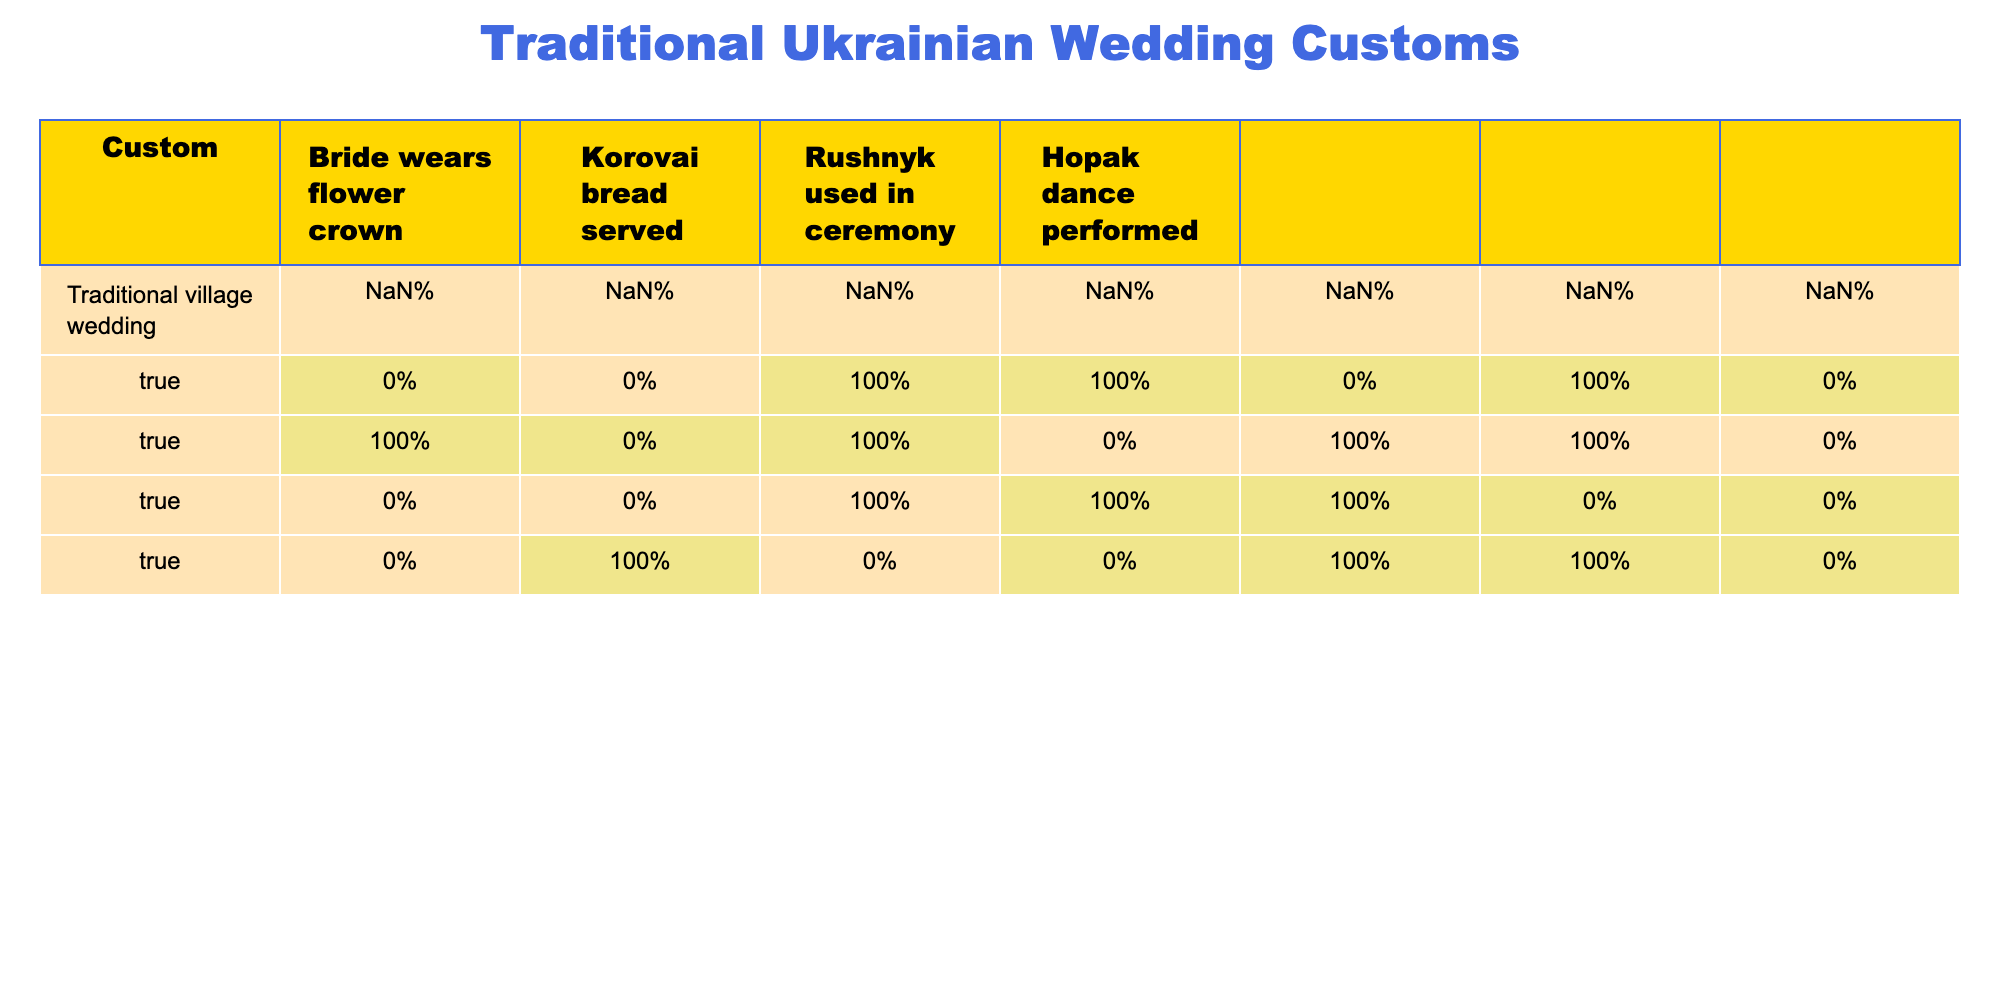What traditional wedding customs involve the bride wearing a flower crown? We can look at the table and list the types of weddings where the bride wears a flower crown. These are: Traditional village wedding, Family-only small ceremony, Mixed Ukrainian-foreign wedding, and Outdoor summer wedding.
Answer: Traditional village wedding, Family-only small ceremony, Mixed Ukrainian-foreign wedding, Outdoor summer wedding How many wedding types serve Korovai bread and perform the Hopak dance? The wedding types that serve Korovai bread are: Traditional village wedding, Modern city-influenced wedding, Family-only small ceremony, Winter wedding, Outdoor summer wedding. In total, there are 5 of them. However, only Traditional village wedding and Winter wedding also perform the Hopak dance (2 in total).
Answer: 2 Is the Rushnyk used in the Modern city-influenced wedding? According to the table, in the row for Modern city-influenced wedding, under the column Rushnyk used in ceremony, the value is FALSE. Therefore, Rushnyk is not used in this type of wedding.
Answer: No Which wedding types do not serve Korovai bread? To determine this, we can look at the table and find the rows where Korovai bread is marked as FALSE. These are: Modern city-influenced wedding and Destination wedding abroad.
Answer: Modern city-influenced wedding, Destination wedding abroad What is the relationship between the presence of the Hopak dance and the use of a Rushnyk in ceremonies? We can examine the table for combinations. The Hopak dance is performed at Traditional village wedding, Winter wedding, and Outdoor summer wedding, while Rushnyk is used in Traditional village wedding, Family-only small ceremony, and Winter wedding. The only overlapping wedding type that has both is Winter wedding.
Answer: They overlap in Winter wedding only How many wedding types have both the bride wearing a flower crown and the use of a Rushnyk? First, we'll identify where the bride wears a flower crown: Traditional village wedding, Family-only small ceremony, Mixed Ukrainian-foreign wedding, and Outdoor summer wedding. Then, we check which of these have Rushnyk: only Traditional village wedding and Family-only small ceremony meet both criteria. Count gives us 2 wedding types.
Answer: 2 Are there any wedding types that do not perform the Hopak dance but use a Rushnyk? Looking through the table, we find that the Family-only small ceremony is the only type that still uses a Rushnyk but does not perform the Hopak dance, marked as FALSE under Hopak dance.
Answer: Yes, Family-only small ceremony How many wedding customs out of those listed perform a Hopak dance? From the table, we tally the rows where Hopak is marked as TRUE. They are: Traditional village wedding, Winter wedding, and Outdoor summer wedding. This gives us a total of 3 wedding types that perform the Hopak dance.
Answer: 3 